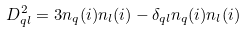<formula> <loc_0><loc_0><loc_500><loc_500>D _ { q l } ^ { 2 } = 3 n _ { q } ( i ) n _ { l } ( i ) - \delta _ { q l } n _ { q } ( i ) n _ { l } ( i )</formula> 